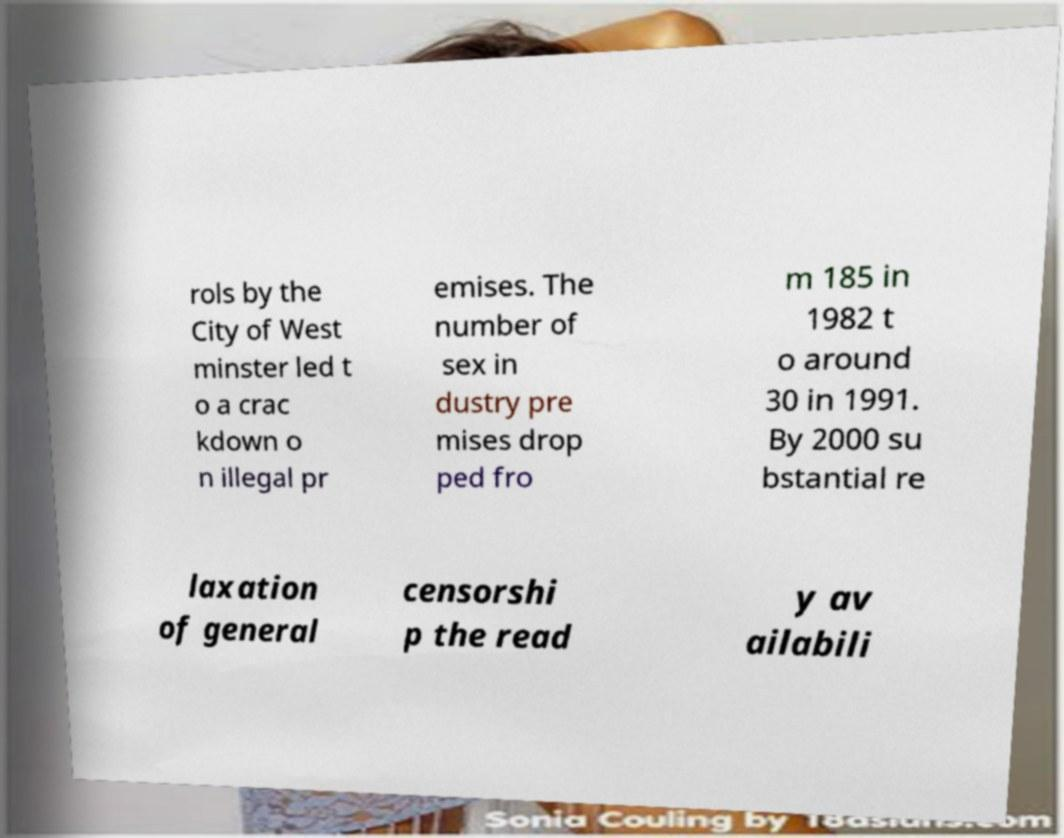Could you assist in decoding the text presented in this image and type it out clearly? rols by the City of West minster led t o a crac kdown o n illegal pr emises. The number of sex in dustry pre mises drop ped fro m 185 in 1982 t o around 30 in 1991. By 2000 su bstantial re laxation of general censorshi p the read y av ailabili 